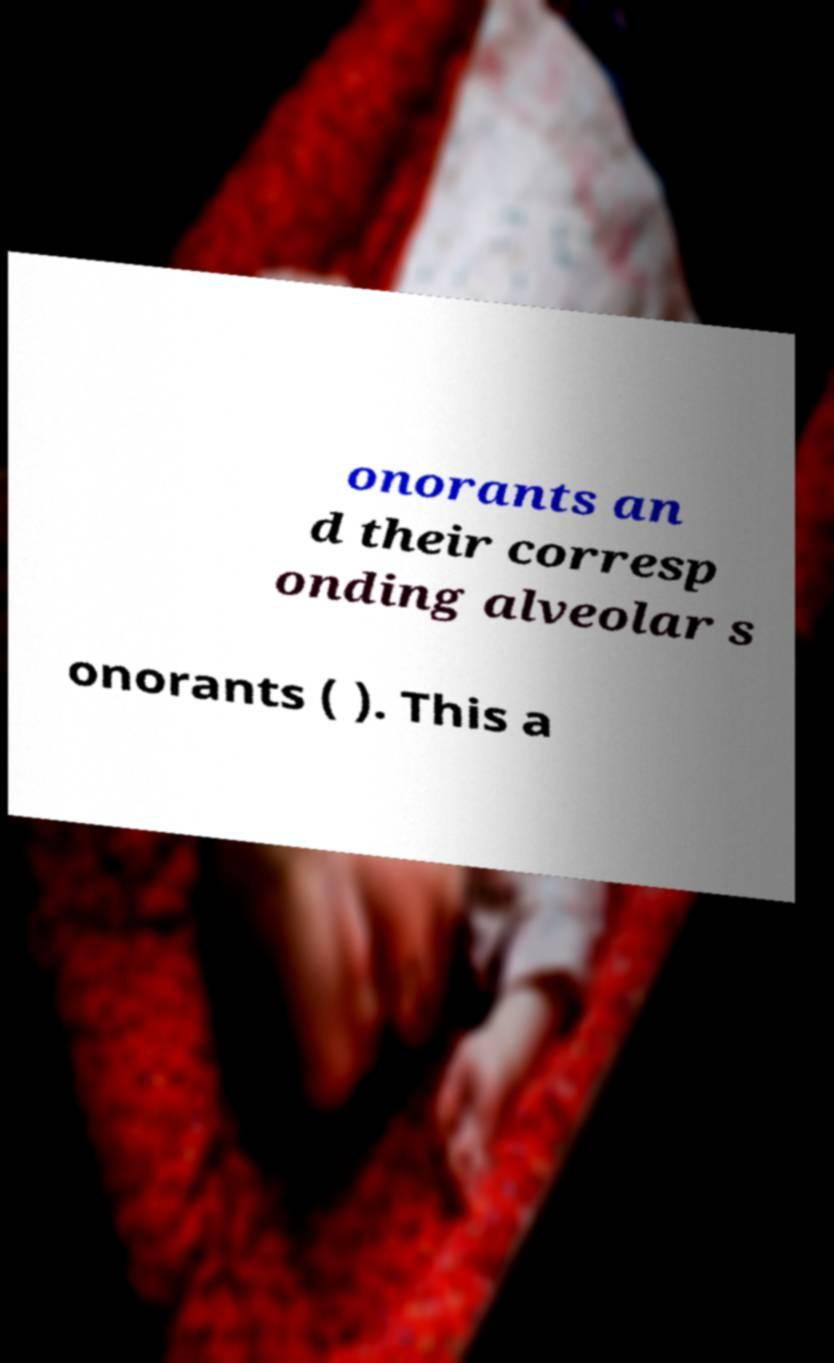Please read and relay the text visible in this image. What does it say? onorants an d their corresp onding alveolar s onorants ( ). This a 